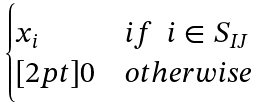Convert formula to latex. <formula><loc_0><loc_0><loc_500><loc_500>\begin{cases} x _ { i } & i f \ \ i \in S _ { I J } \\ [ 2 p t ] 0 & o t h e r w i s e \end{cases}</formula> 